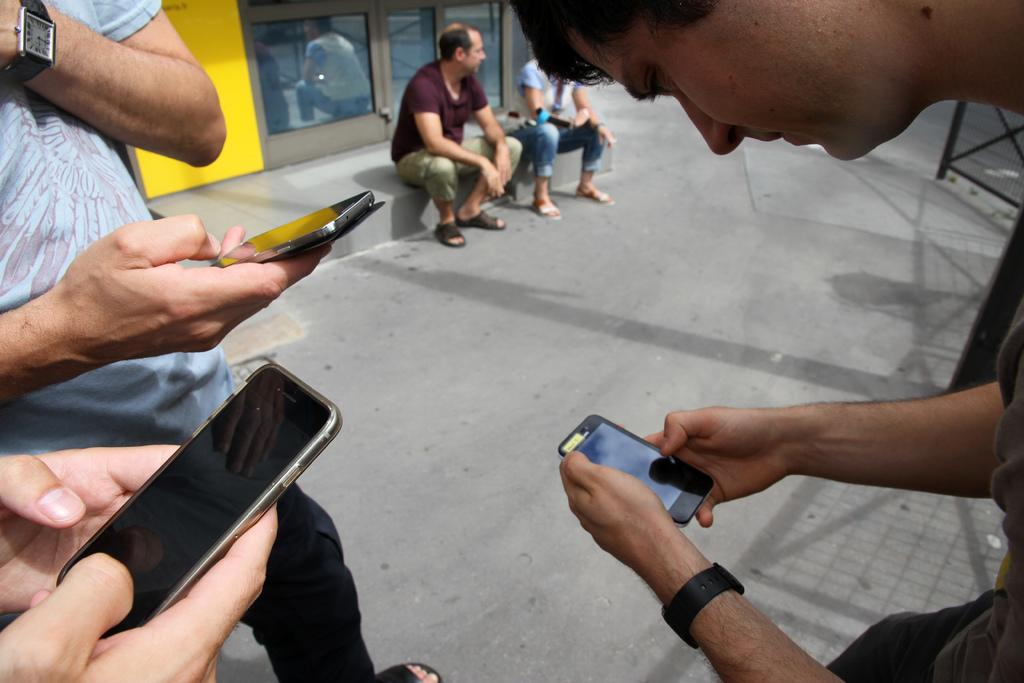What are the people in the image holding? The people in the image are holding mobile phones. Where are the people located in the image? The people are sitting in the background of the image. What type of fruit is being crushed by the people in the image? There is no fruit being crushed in the image; the people are holding mobile phones. 